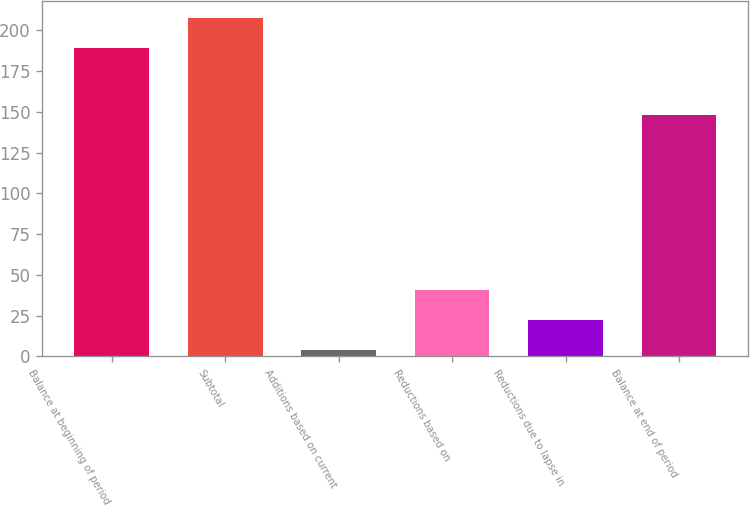Convert chart to OTSL. <chart><loc_0><loc_0><loc_500><loc_500><bar_chart><fcel>Balance at beginning of period<fcel>Subtotal<fcel>Additions based on current<fcel>Reductions based on<fcel>Reductions due to lapse in<fcel>Balance at end of period<nl><fcel>189<fcel>207.5<fcel>4<fcel>41<fcel>22.5<fcel>148<nl></chart> 